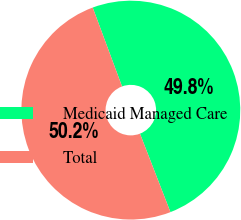<chart> <loc_0><loc_0><loc_500><loc_500><pie_chart><fcel>Medicaid Managed Care<fcel>Total<nl><fcel>49.77%<fcel>50.23%<nl></chart> 